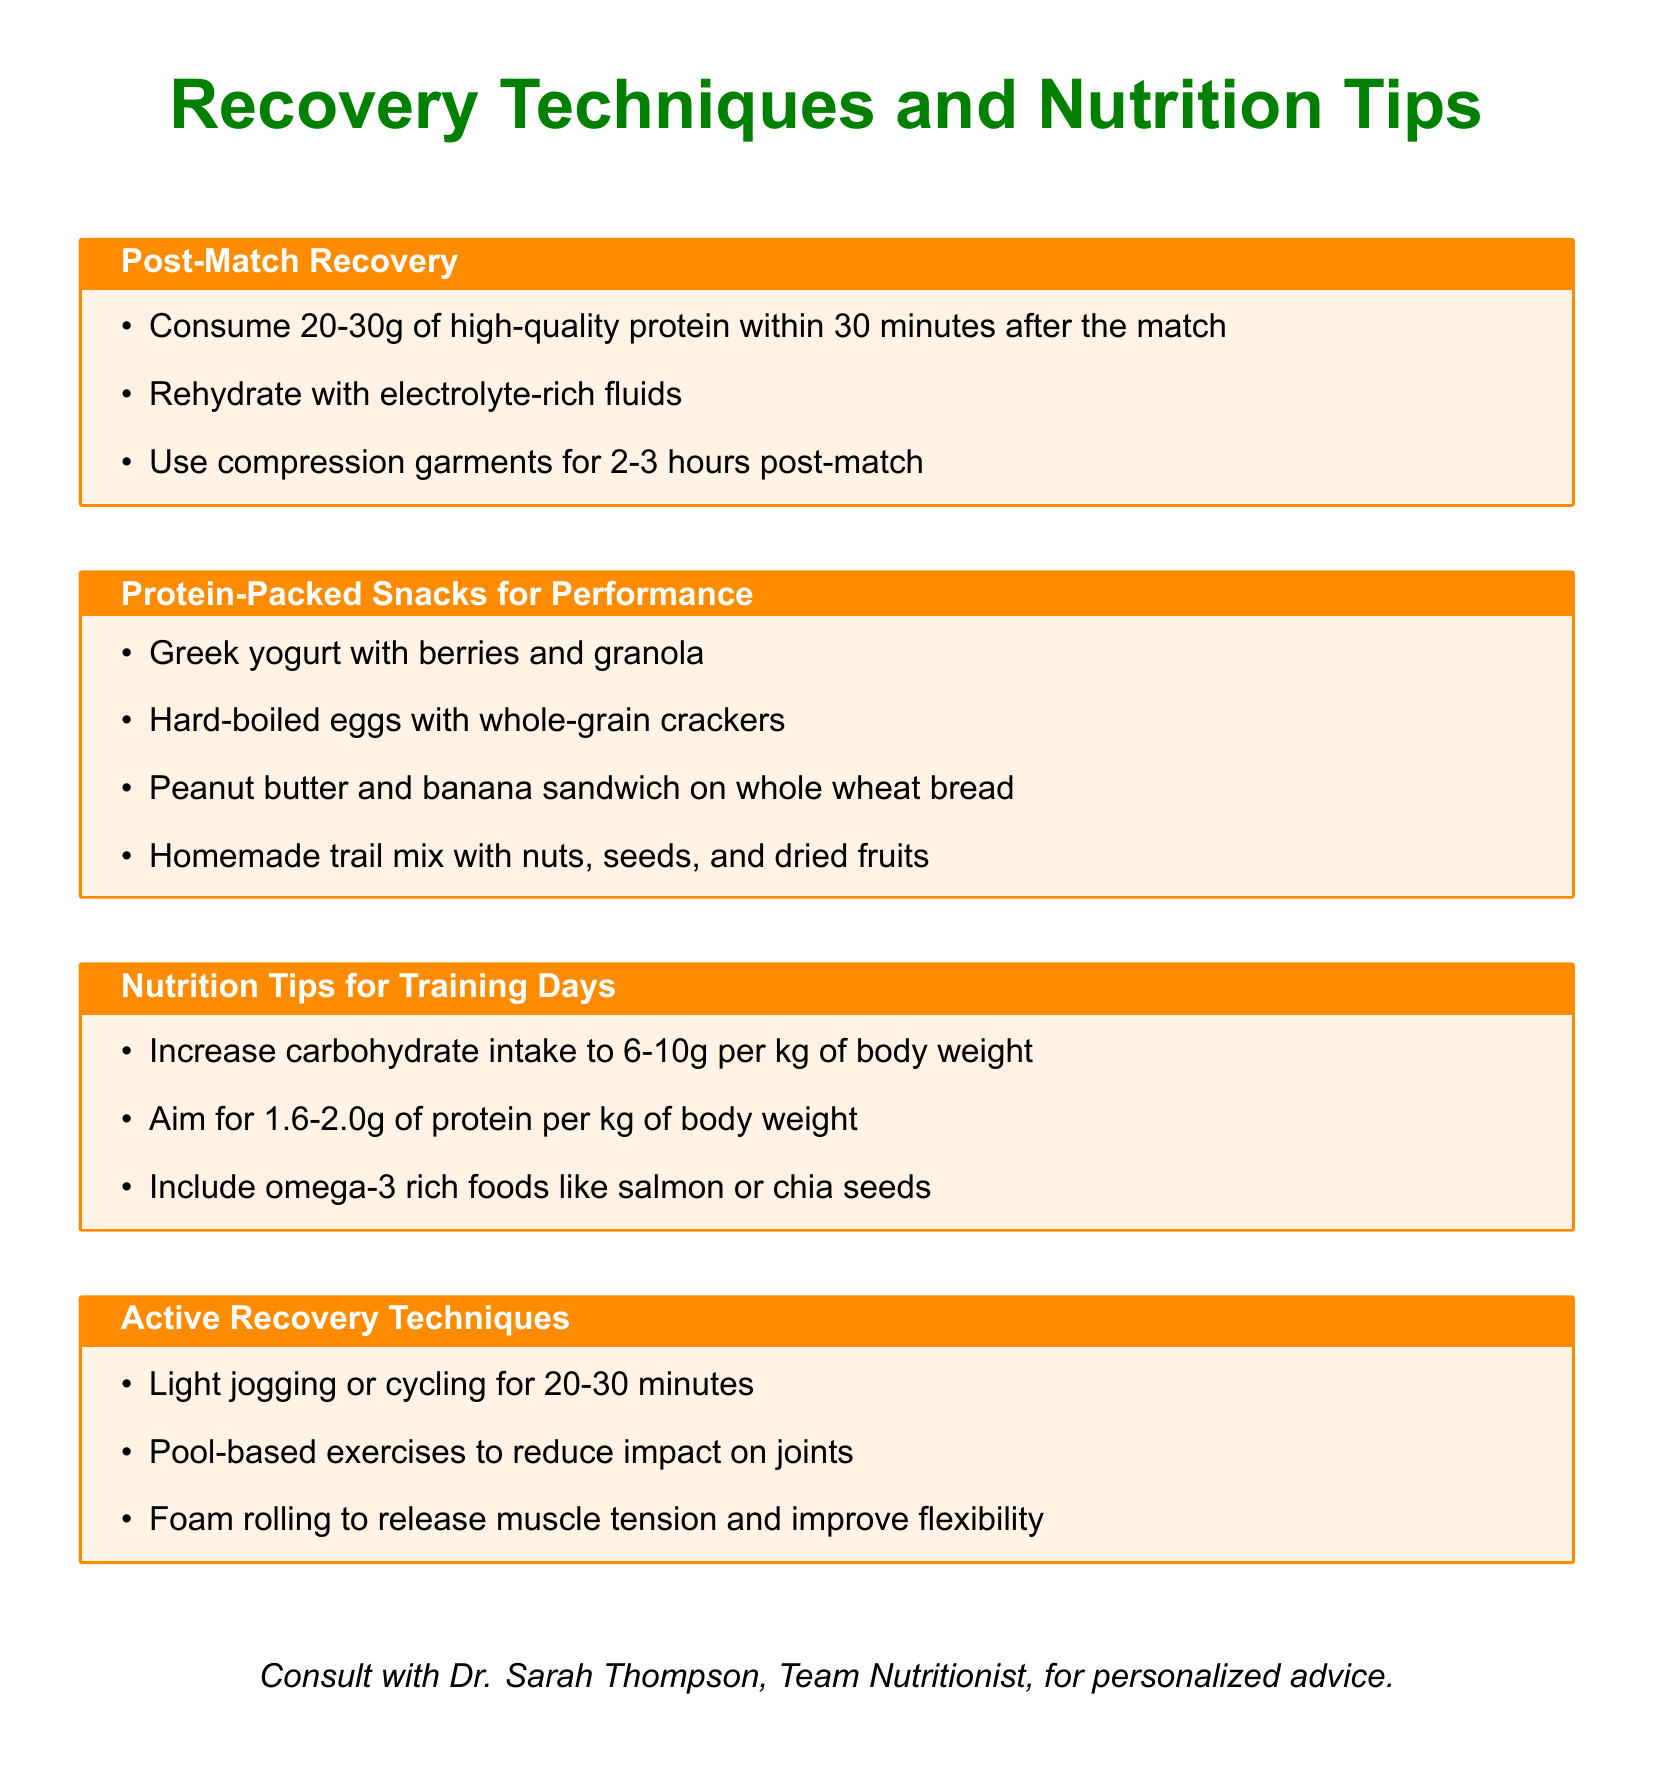What is the recommended protein intake post-match? The document states to consume 20-30g of high-quality protein within 30 minutes after the match.
Answer: 20-30g What should be consumed after a match for rehydration? The document suggests rehydrating with electrolyte-rich fluids such as Gatorade or coconut water.
Answer: Electrolyte-rich fluids What is one type of protein-packed snack listed? The document provides several examples, including Greek yogurt with berries and granola.
Answer: Greek yogurt with berries and granola How many grams of carbohydrates should be consumed per kg of body weight on training days? The document states to increase carbohydrate intake to 6-10g per kg of body weight.
Answer: 6-10g Which food is recommended for omega-3 intake? The document mentions including omega-3 rich foods like salmon or chia seeds.
Answer: Salmon or chia seeds What is one active recovery technique mentioned? According to the document, light jogging or cycling for 20-30 minutes is suggested.
Answer: Light jogging or cycling Who should be consulted for personalized nutrition advice? The document indicates to consult with Dr. Sarah Thompson, Team Nutritionist, for personalized advice.
Answer: Dr. Sarah Thompson How long should compression garments be used post-match? The document specifies using compression garments for 2-3 hours post-match.
Answer: 2-3 hours 